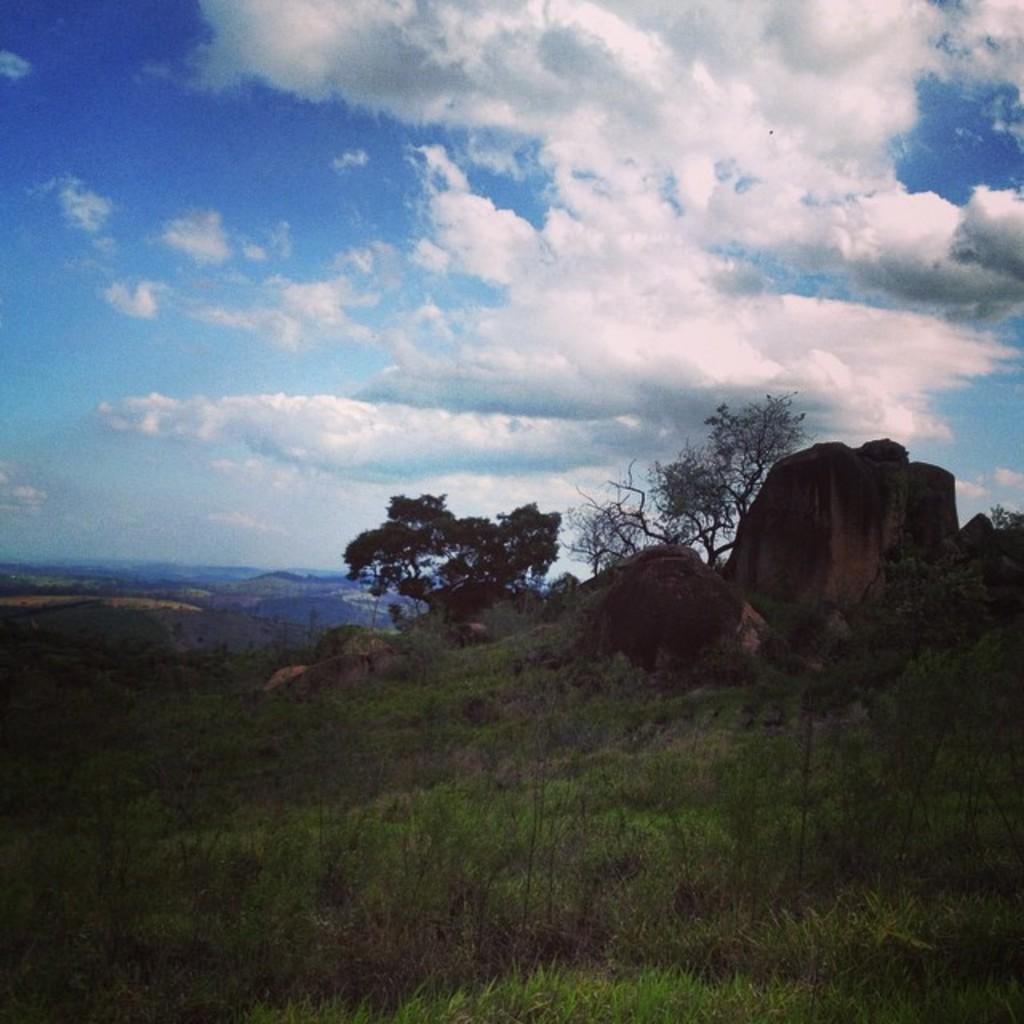Describe this image in one or two sentences. In this image there are grass, trees, hills and the sky. 